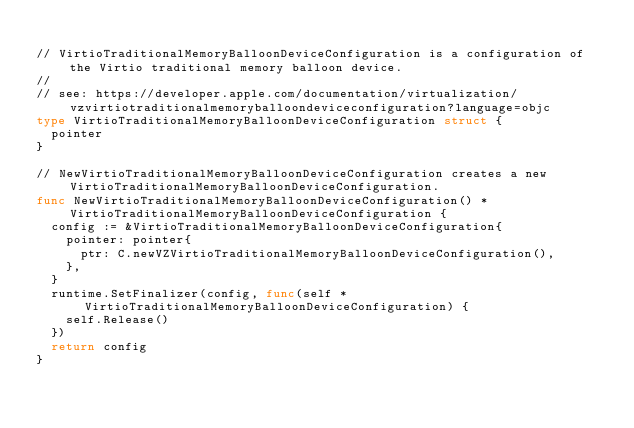Convert code to text. <code><loc_0><loc_0><loc_500><loc_500><_Go_>
// VirtioTraditionalMemoryBalloonDeviceConfiguration is a configuration of the Virtio traditional memory balloon device.
//
// see: https://developer.apple.com/documentation/virtualization/vzvirtiotraditionalmemoryballoondeviceconfiguration?language=objc
type VirtioTraditionalMemoryBalloonDeviceConfiguration struct {
	pointer
}

// NewVirtioTraditionalMemoryBalloonDeviceConfiguration creates a new VirtioTraditionalMemoryBalloonDeviceConfiguration.
func NewVirtioTraditionalMemoryBalloonDeviceConfiguration() *VirtioTraditionalMemoryBalloonDeviceConfiguration {
	config := &VirtioTraditionalMemoryBalloonDeviceConfiguration{
		pointer: pointer{
			ptr: C.newVZVirtioTraditionalMemoryBalloonDeviceConfiguration(),
		},
	}
	runtime.SetFinalizer(config, func(self *VirtioTraditionalMemoryBalloonDeviceConfiguration) {
		self.Release()
	})
	return config
}
</code> 